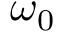<formula> <loc_0><loc_0><loc_500><loc_500>\omega _ { 0 }</formula> 